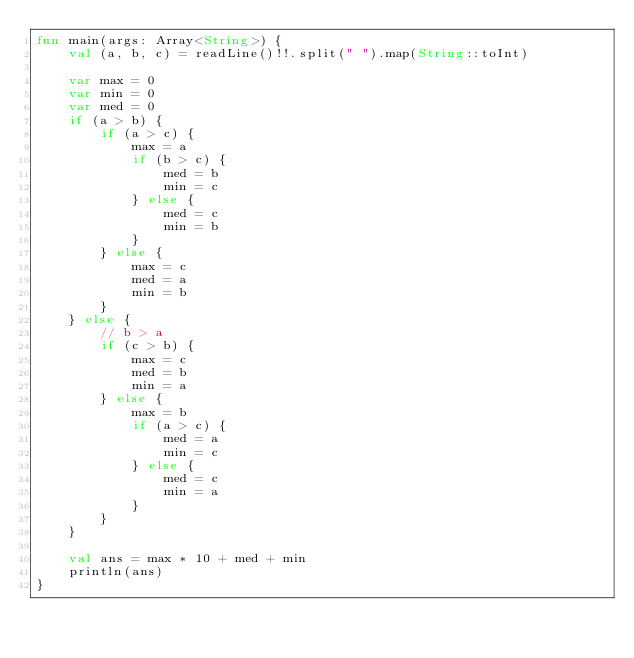<code> <loc_0><loc_0><loc_500><loc_500><_Kotlin_>fun main(args: Array<String>) {
    val (a, b, c) = readLine()!!.split(" ").map(String::toInt)

    var max = 0
    var min = 0
    var med = 0
    if (a > b) {
        if (a > c) {
            max = a
            if (b > c) {
                med = b
                min = c
            } else {
                med = c
                min = b
            }
        } else {
            max = c
            med = a
            min = b
        }
    } else {
        // b > a
        if (c > b) {
            max = c
            med = b
            min = a
        } else {
            max = b
            if (a > c) {
                med = a
                min = c
            } else {
                med = c
                min = a
            }
        }
    }

    val ans = max * 10 + med + min
    println(ans)
}</code> 